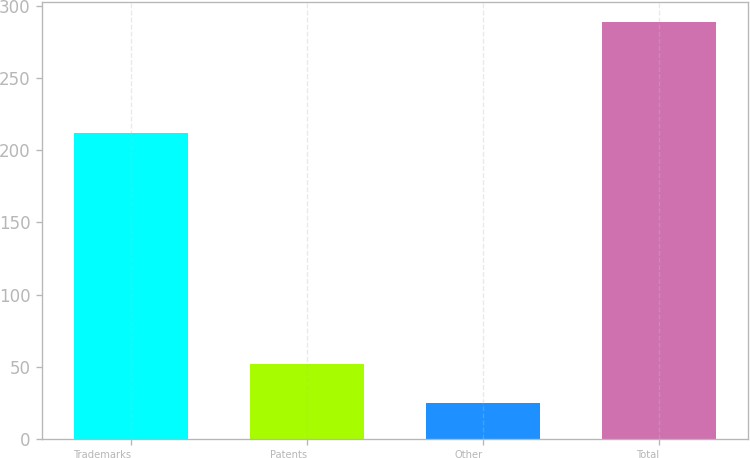Convert chart. <chart><loc_0><loc_0><loc_500><loc_500><bar_chart><fcel>Trademarks<fcel>Patents<fcel>Other<fcel>Total<nl><fcel>211.7<fcel>52<fcel>24.9<fcel>288.6<nl></chart> 